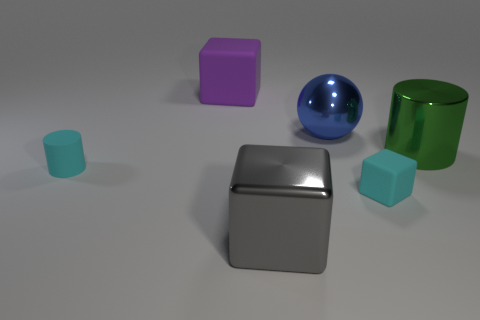Subtract all gray shiny cubes. How many cubes are left? 2 Add 4 big gray blocks. How many objects exist? 10 Subtract 1 cubes. How many cubes are left? 2 Subtract 0 red cylinders. How many objects are left? 6 Subtract all cylinders. How many objects are left? 4 Subtract all red balls. Subtract all blue cubes. How many balls are left? 1 Subtract all large green metallic cubes. Subtract all purple matte objects. How many objects are left? 5 Add 1 large gray cubes. How many large gray cubes are left? 2 Add 2 big gray rubber objects. How many big gray rubber objects exist? 2 